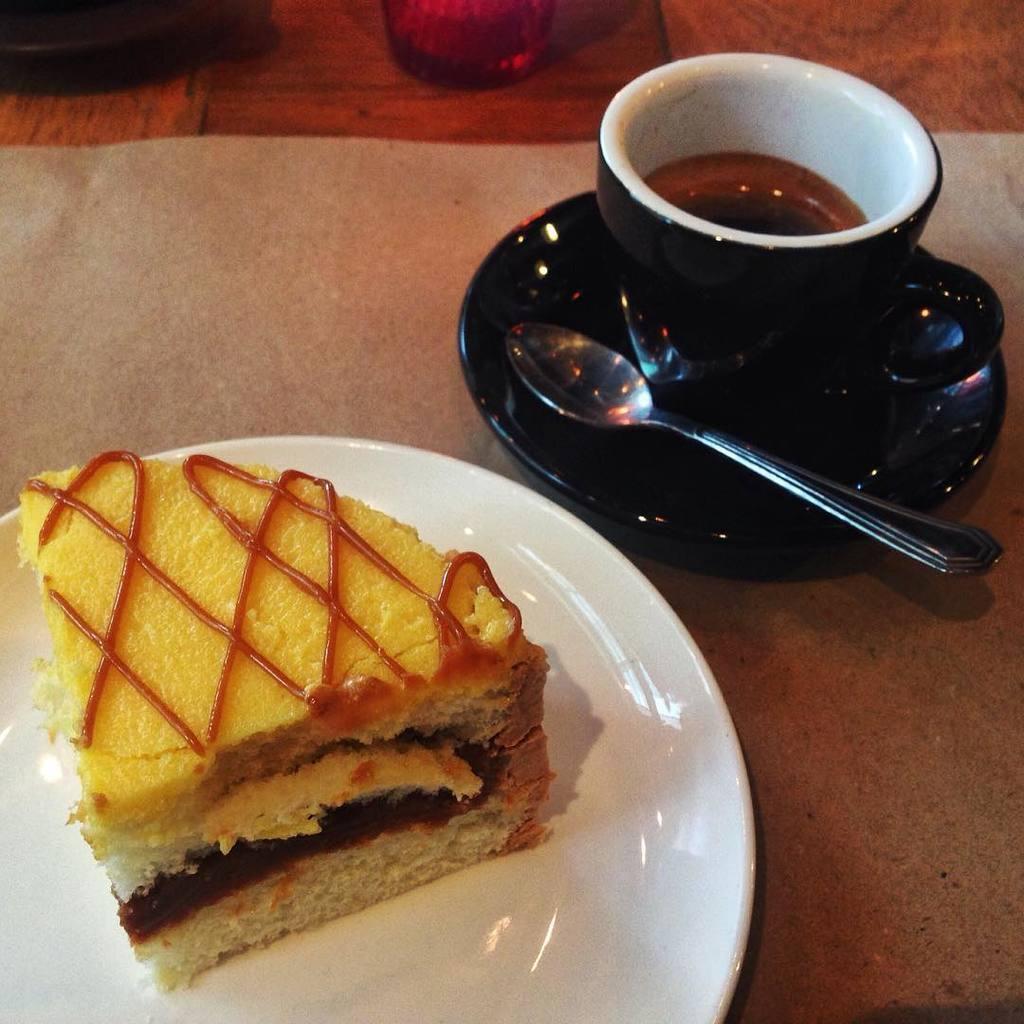Can you describe this image briefly? Here I can see a cake piece which is placed on a white color saucer. Beside this, I can see another saucer and a cup which are in black color. Along with the cup there is a spoon. These objects are placed on a table. On the top I can see two glasses. 